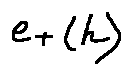<formula> <loc_0><loc_0><loc_500><loc_500>e + ( h )</formula> 